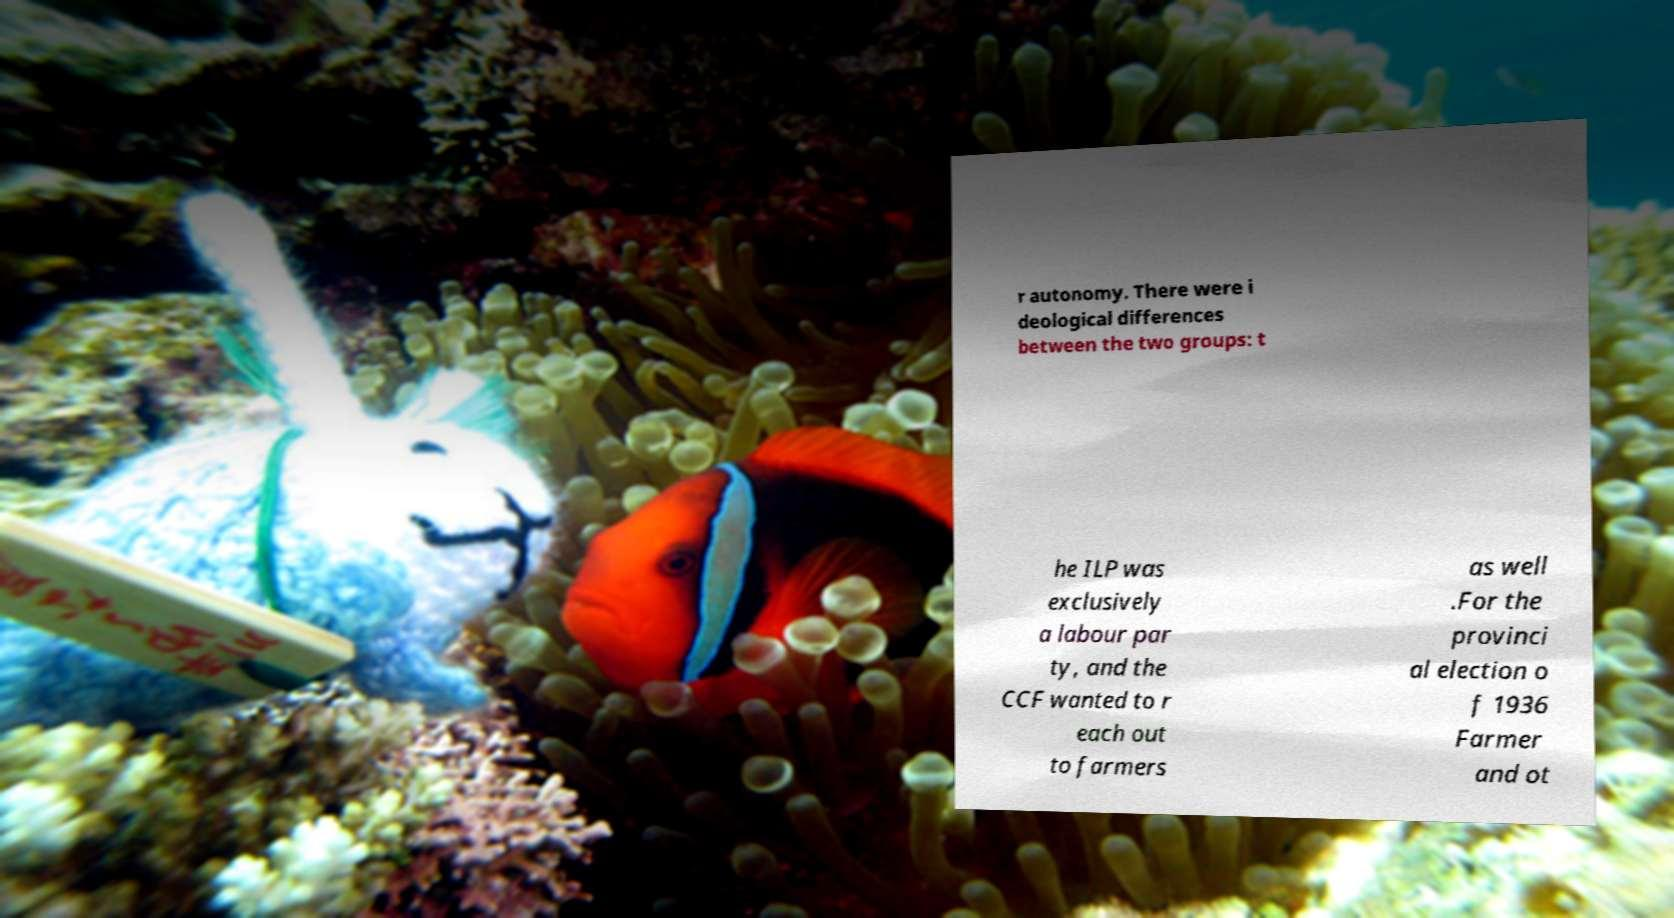Could you extract and type out the text from this image? r autonomy. There were i deological differences between the two groups: t he ILP was exclusively a labour par ty, and the CCF wanted to r each out to farmers as well .For the provinci al election o f 1936 Farmer and ot 